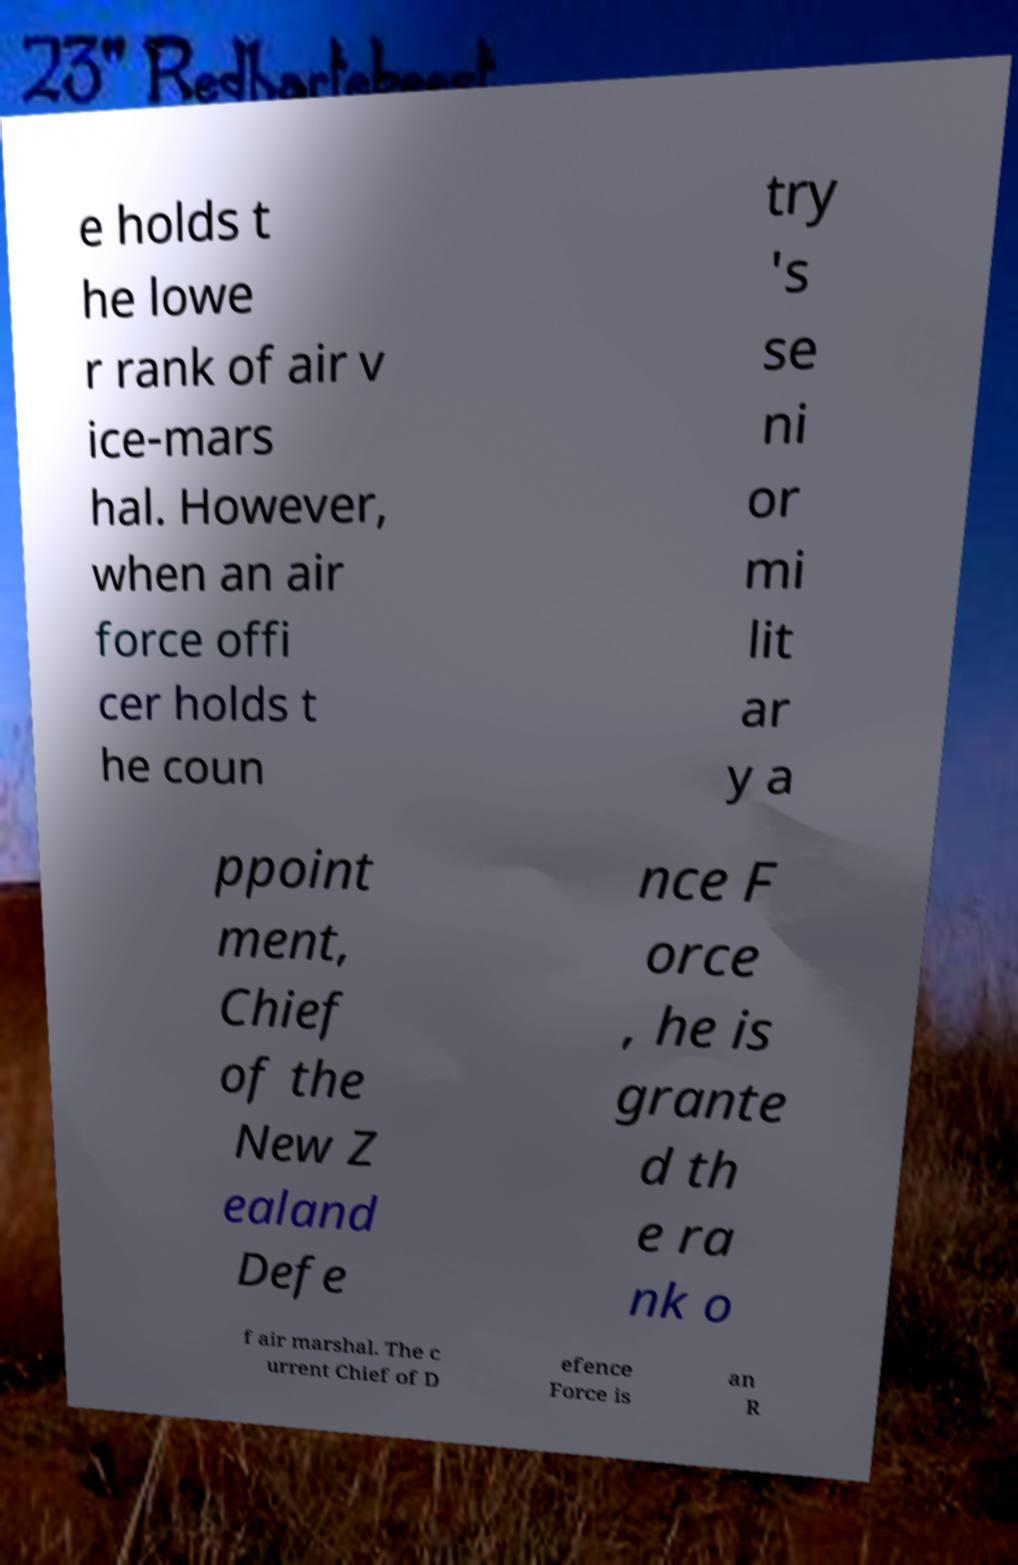Could you assist in decoding the text presented in this image and type it out clearly? e holds t he lowe r rank of air v ice-mars hal. However, when an air force offi cer holds t he coun try 's se ni or mi lit ar y a ppoint ment, Chief of the New Z ealand Defe nce F orce , he is grante d th e ra nk o f air marshal. The c urrent Chief of D efence Force is an R 